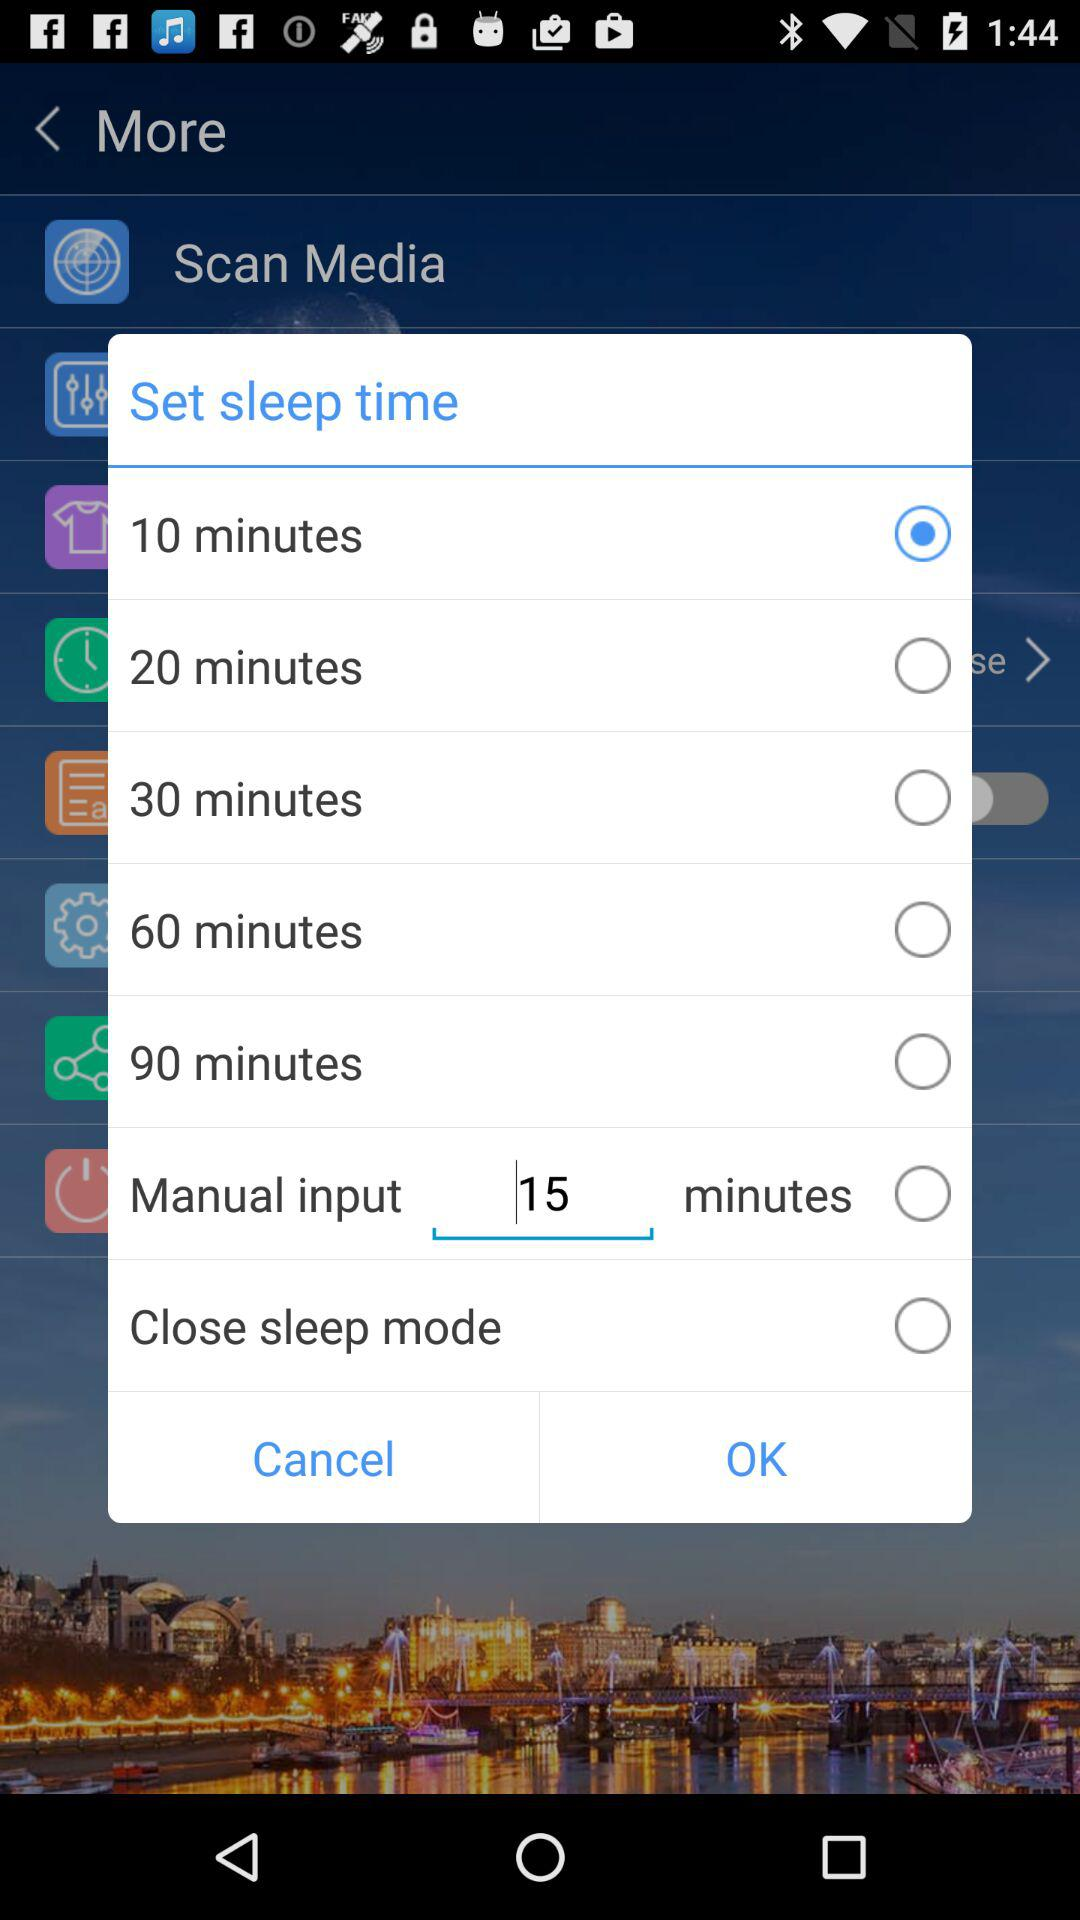Which option has been chosen for the set sleep time? The chosen option is "10 minutes". 